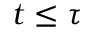Convert formula to latex. <formula><loc_0><loc_0><loc_500><loc_500>t \leq \tau</formula> 